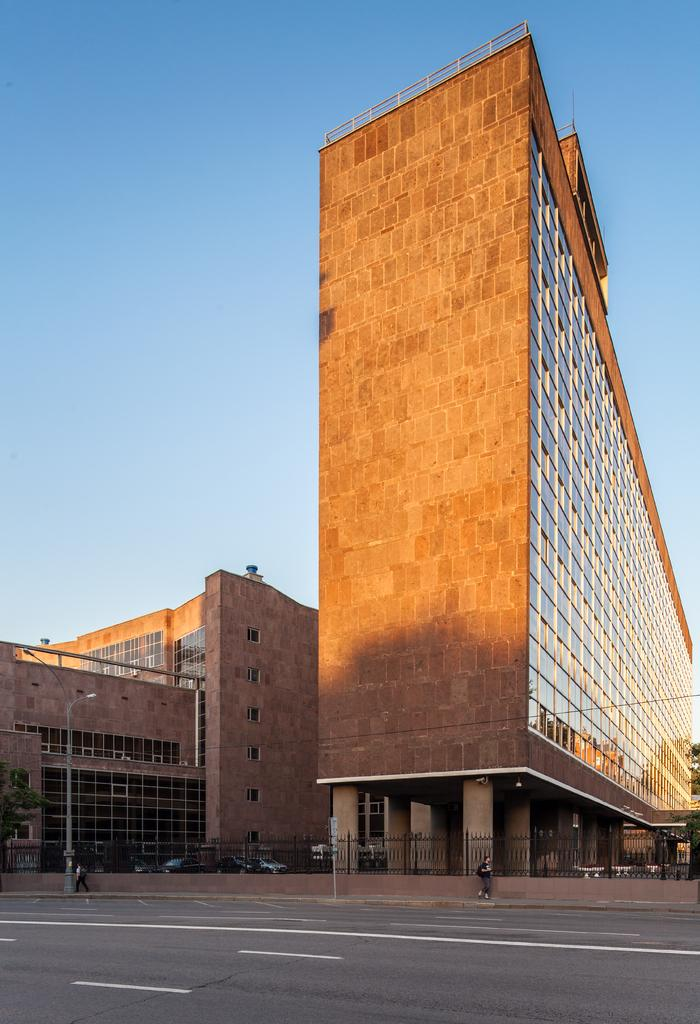How many brown buildings are in the image? There are two brown buildings in the image. What can be seen between the brown buildings? There are vehicles between the buildings. What type of structure is present in the image, separating the buildings and vehicles? There is a fence wall in the image. Are there any people visible in the image? Yes, two persons are standing beside the fence wall. What letter is the queen holding in the image? There is no queen or letter present in the image. 